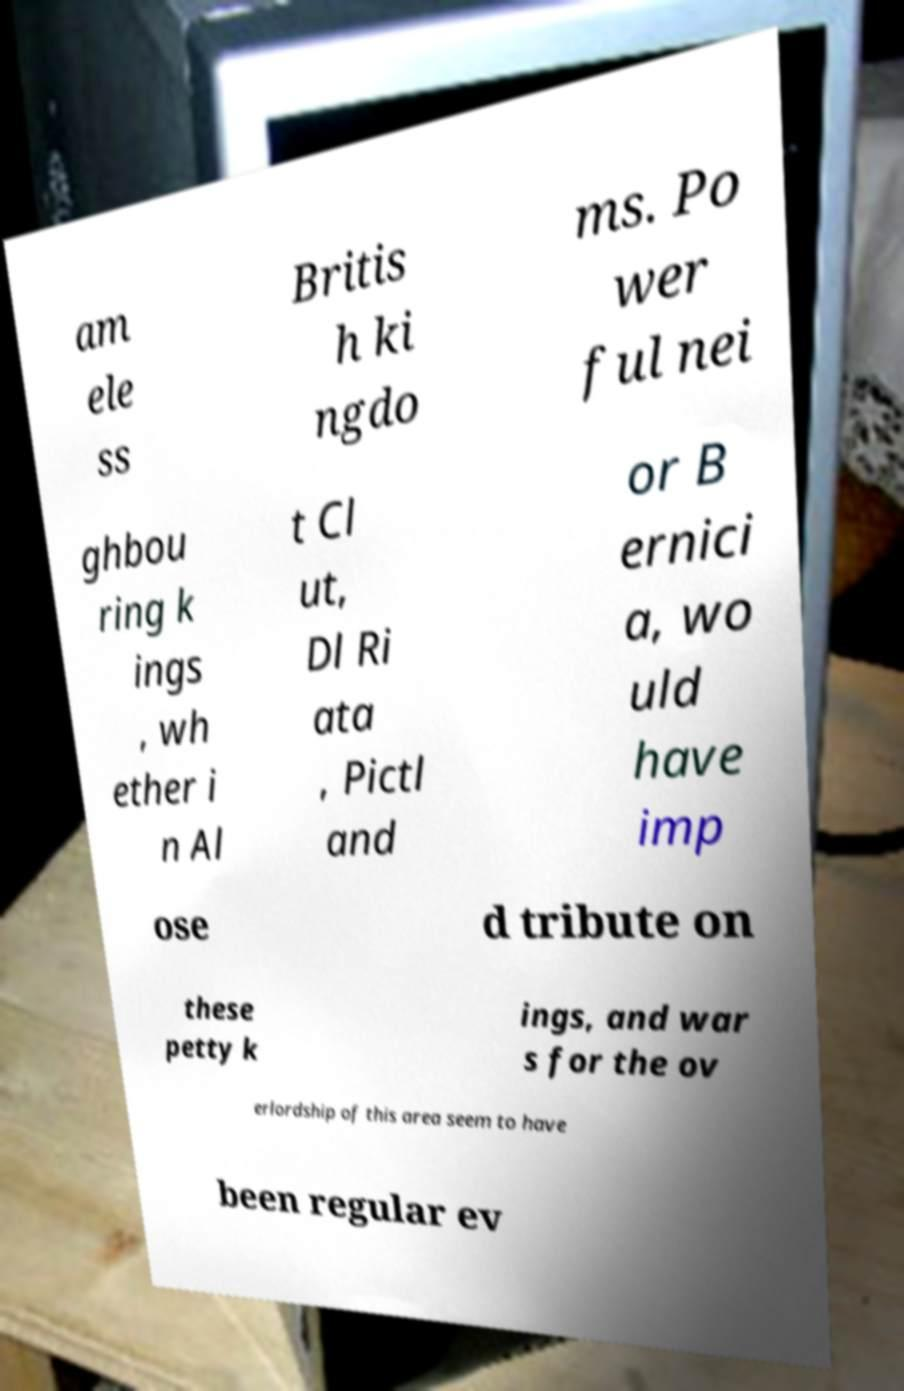Please identify and transcribe the text found in this image. am ele ss Britis h ki ngdo ms. Po wer ful nei ghbou ring k ings , wh ether i n Al t Cl ut, Dl Ri ata , Pictl and or B ernici a, wo uld have imp ose d tribute on these petty k ings, and war s for the ov erlordship of this area seem to have been regular ev 